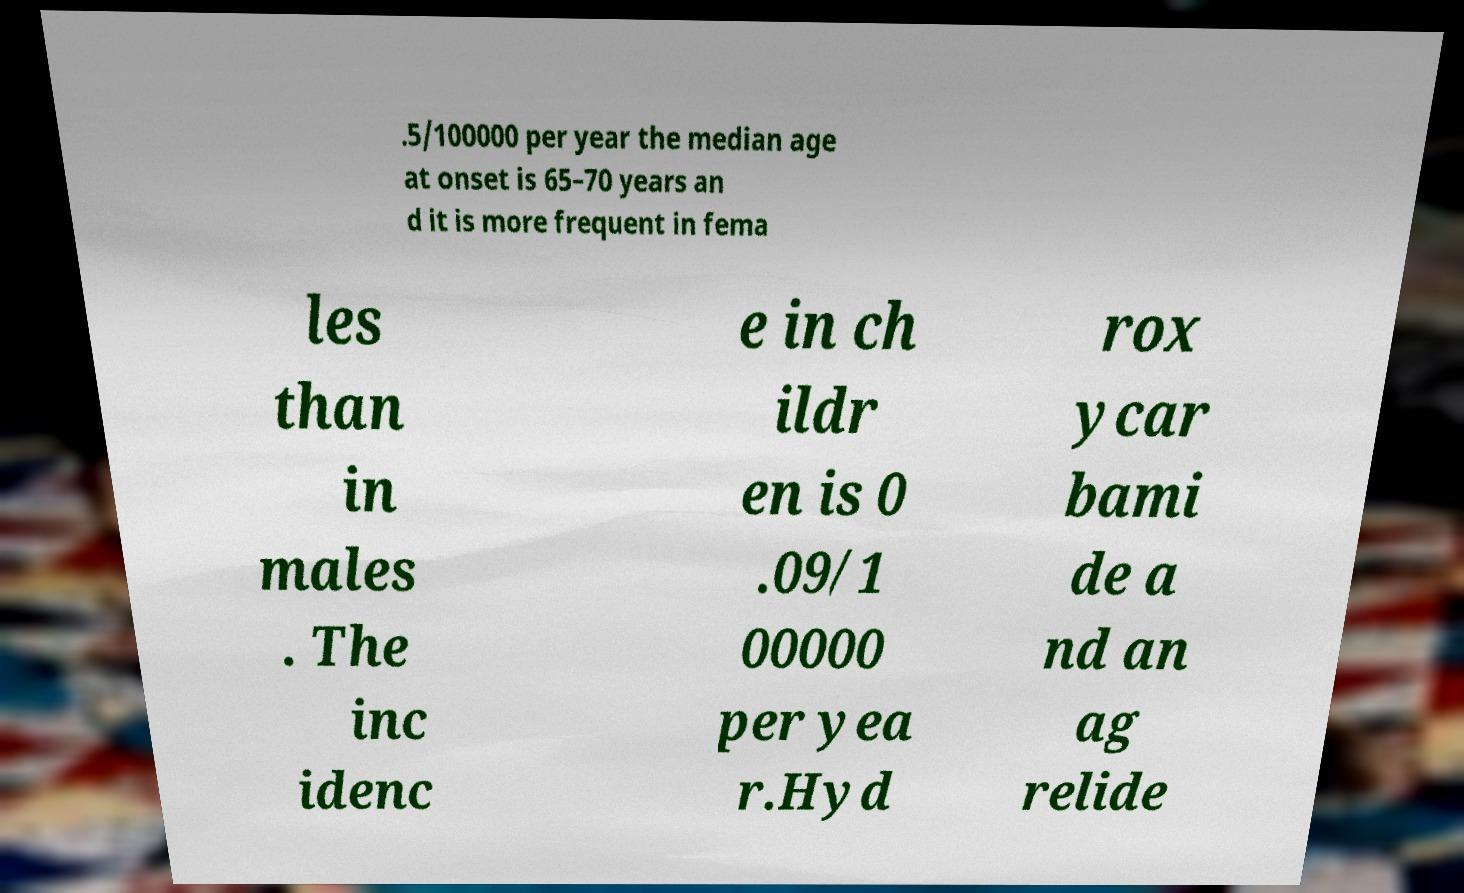Please read and relay the text visible in this image. What does it say? .5/100000 per year the median age at onset is 65–70 years an d it is more frequent in fema les than in males . The inc idenc e in ch ildr en is 0 .09/1 00000 per yea r.Hyd rox ycar bami de a nd an ag relide 